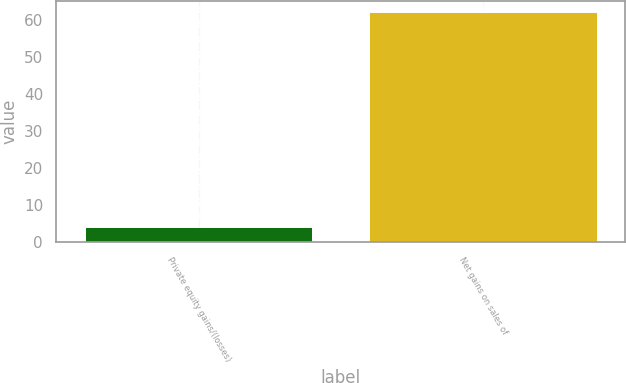Convert chart. <chart><loc_0><loc_0><loc_500><loc_500><bar_chart><fcel>Private equity gains/(losses)<fcel>Net gains on sales of<nl><fcel>4<fcel>62<nl></chart> 